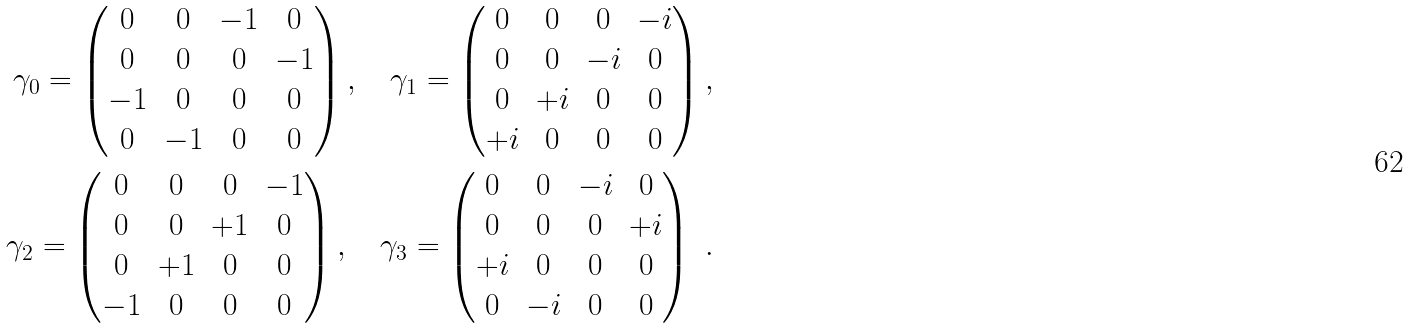Convert formula to latex. <formula><loc_0><loc_0><loc_500><loc_500>\gamma _ { 0 } = \begin{pmatrix} 0 & 0 & - 1 & 0 \\ 0 & 0 & 0 & - 1 \\ - 1 & 0 & 0 & 0 \\ 0 & - 1 & 0 & 0 \\ \end{pmatrix} , \quad \gamma _ { 1 } = \begin{pmatrix} 0 & 0 & 0 & - i \\ 0 & 0 & - i & 0 \\ 0 & + i & 0 & 0 \\ + i & 0 & 0 & 0 \\ \end{pmatrix} , \\ \gamma _ { 2 } = \begin{pmatrix} 0 & 0 & 0 & - 1 \\ 0 & 0 & + 1 & 0 \\ 0 & + 1 & 0 & 0 \\ - 1 & 0 & 0 & 0 \\ \end{pmatrix} , \quad \gamma _ { 3 } = \begin{pmatrix} 0 & 0 & - i & 0 \\ 0 & 0 & 0 & + i \\ + i & 0 & 0 & 0 \\ 0 & - i & 0 & 0 \\ \end{pmatrix} \ . \\</formula> 